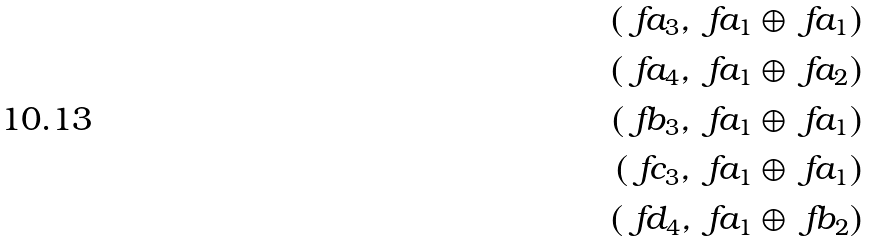<formula> <loc_0><loc_0><loc_500><loc_500>( \ f a _ { 3 } , \ f a _ { 1 } \oplus \ f a _ { 1 } ) \\ ( \ f a _ { 4 } , \ f a _ { 1 } \oplus \ f a _ { 2 } ) \\ ( \ f b _ { 3 } , \ f a _ { 1 } \oplus \ f a _ { 1 } ) \\ ( \ f c _ { 3 } , \ f a _ { 1 } \oplus \ f a _ { 1 } ) \\ ( \ f d _ { 4 } , \ f a _ { 1 } \oplus \ f b _ { 2 } )</formula> 